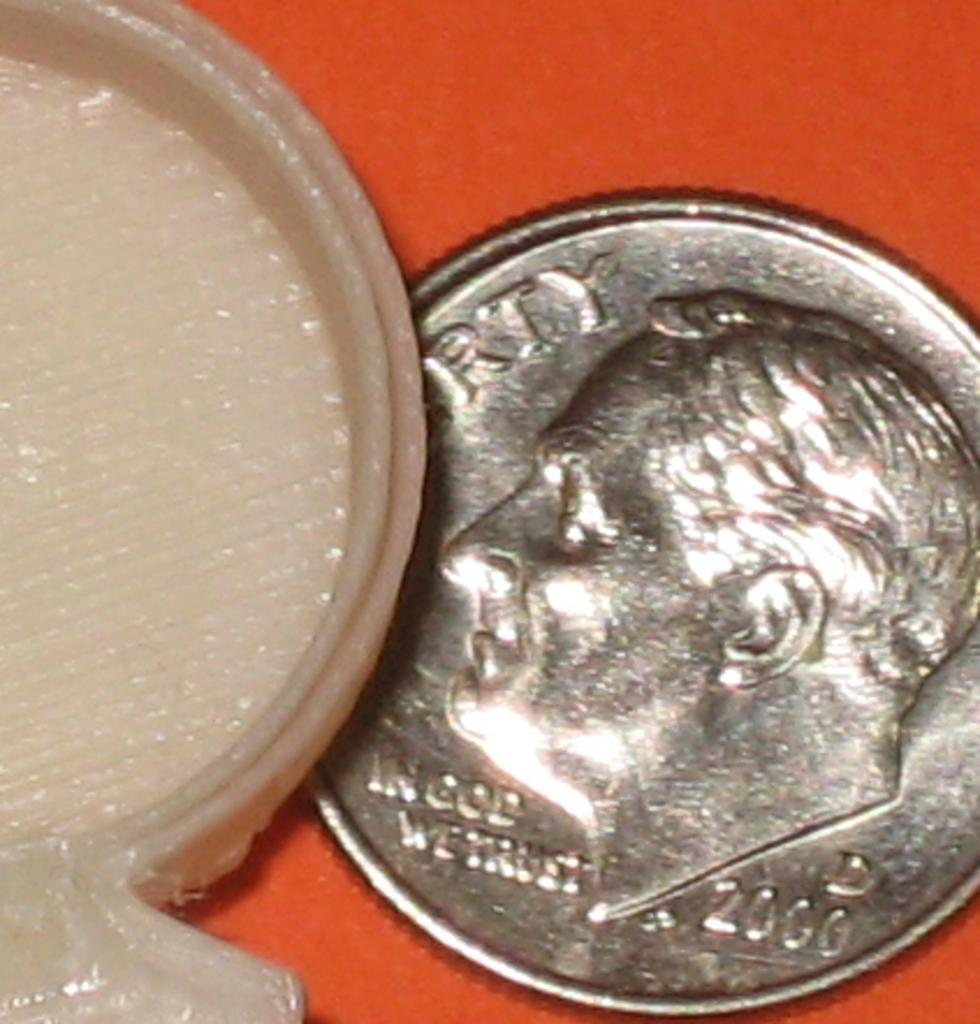<image>
Offer a succinct explanation of the picture presented. A silver Liberty In God We Trust coin from 2000 